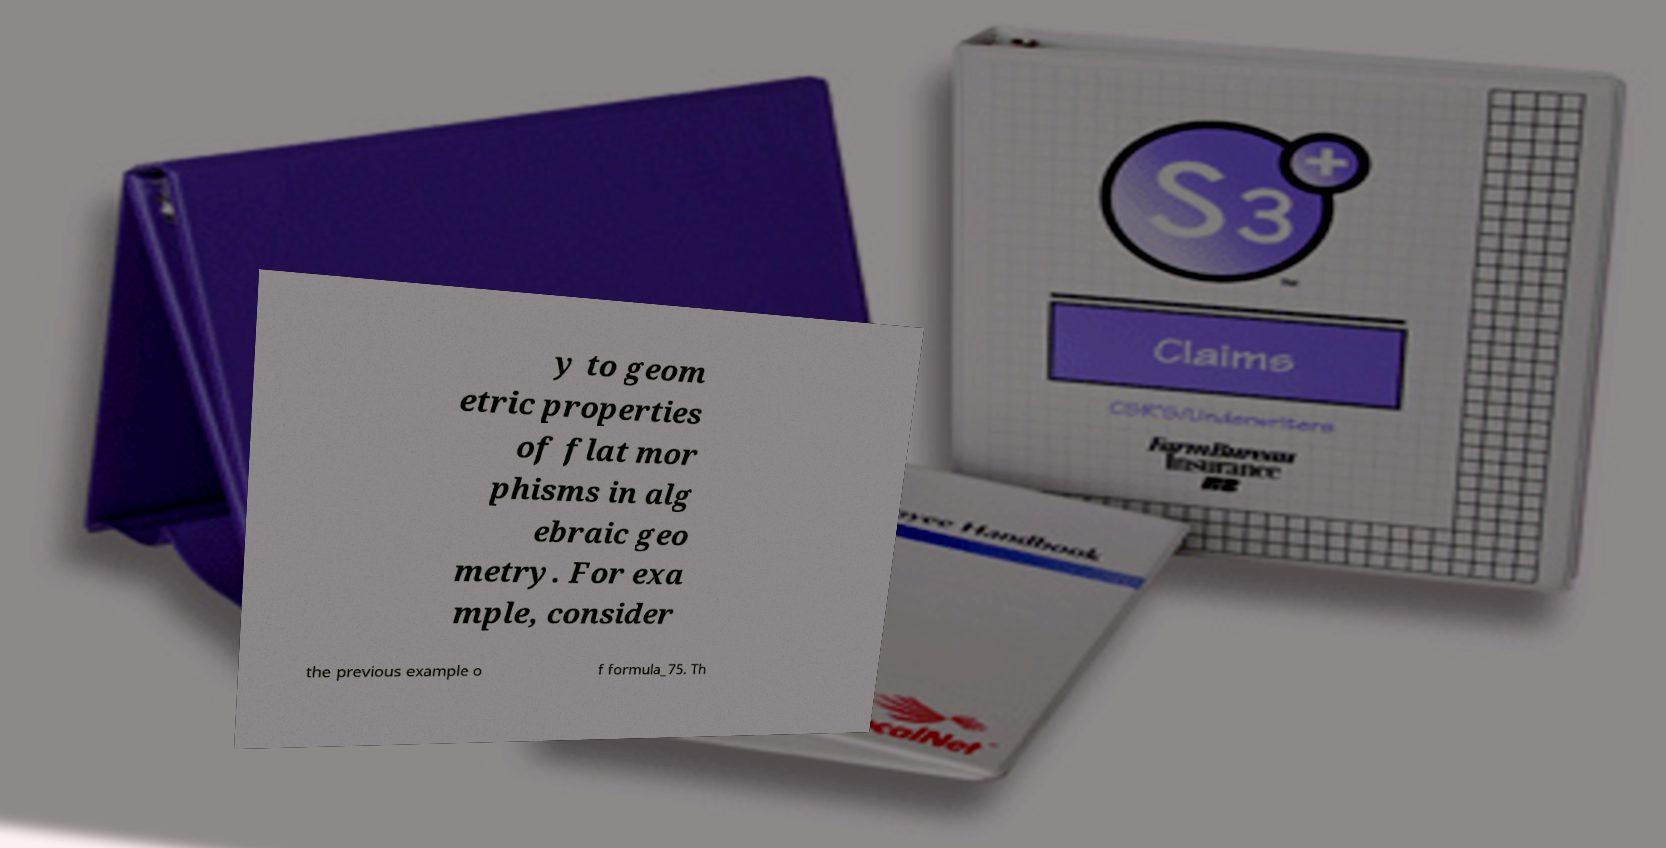What messages or text are displayed in this image? I need them in a readable, typed format. y to geom etric properties of flat mor phisms in alg ebraic geo metry. For exa mple, consider the previous example o f formula_75. Th 